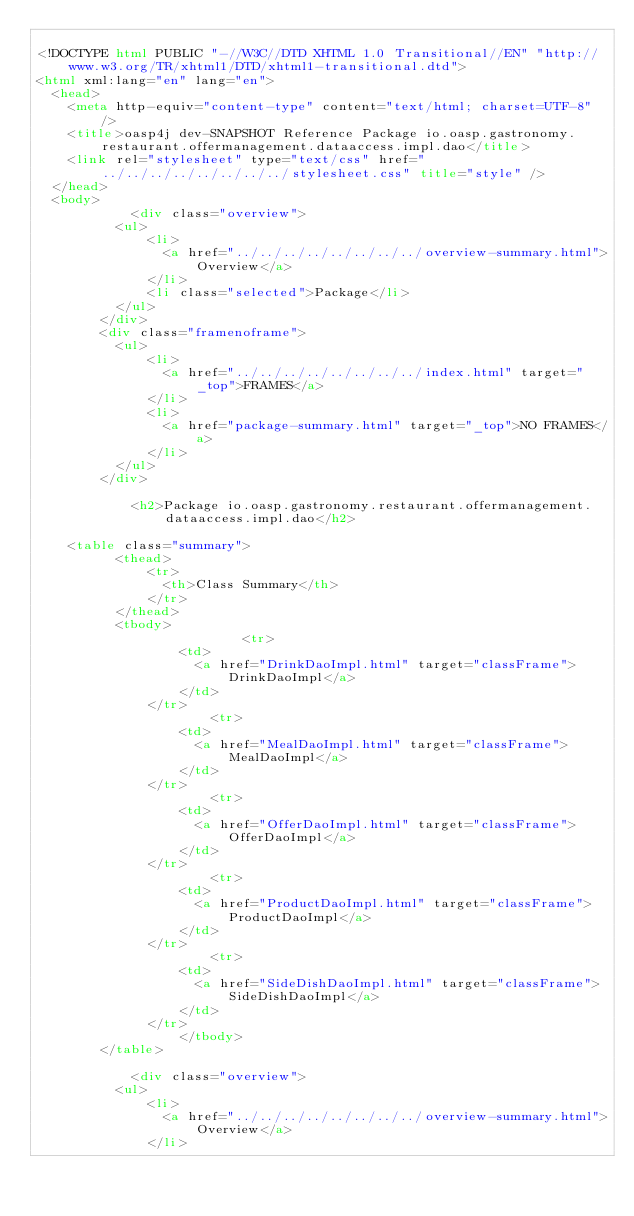Convert code to text. <code><loc_0><loc_0><loc_500><loc_500><_HTML_>
<!DOCTYPE html PUBLIC "-//W3C//DTD XHTML 1.0 Transitional//EN" "http://www.w3.org/TR/xhtml1/DTD/xhtml1-transitional.dtd">
<html xml:lang="en" lang="en">
	<head>
		<meta http-equiv="content-type" content="text/html; charset=UTF-8" />
		<title>oasp4j dev-SNAPSHOT Reference Package io.oasp.gastronomy.restaurant.offermanagement.dataaccess.impl.dao</title>
		<link rel="stylesheet" type="text/css" href="../../../../../../../../stylesheet.css" title="style" />
	</head>
	<body>
		      	<div class="overview">
        	<ul>
          		<li>
            		<a href="../../../../../../../../overview-summary.html">Overview</a>
          		</li>
          		<li class="selected">Package</li>
        	</ul>
      	</div>
      	<div class="framenoframe">
        	<ul>
          		<li>
            		<a href="../../../../../../../../index.html" target="_top">FRAMES</a>
          		</li>
          		<li>
            		<a href="package-summary.html" target="_top">NO FRAMES</a>
          		</li>
        	</ul>
      	</div>
		
		      	<h2>Package io.oasp.gastronomy.restaurant.offermanagement.dataaccess.impl.dao</h2>

		<table class="summary">
        	<thead>
          		<tr>
            		<th>Class Summary</th>
          		</tr>
        	</thead>
        	<tbody>
        		            	<tr>
              		<td>
                		<a href="DrinkDaoImpl.html" target="classFrame">DrinkDaoImpl</a>
              		</td>
            	</tr>
				            	<tr>
              		<td>
                		<a href="MealDaoImpl.html" target="classFrame">MealDaoImpl</a>
              		</td>
            	</tr>
				            	<tr>
              		<td>
                		<a href="OfferDaoImpl.html" target="classFrame">OfferDaoImpl</a>
              		</td>
            	</tr>
				            	<tr>
              		<td>
                		<a href="ProductDaoImpl.html" target="classFrame">ProductDaoImpl</a>
              		</td>
            	</tr>
				            	<tr>
              		<td>
                		<a href="SideDishDaoImpl.html" target="classFrame">SideDishDaoImpl</a>
              		</td>
            	</tr>
				        	</tbody>
      	</table>
		
		      	<div class="overview">
        	<ul>
          		<li>
            		<a href="../../../../../../../../overview-summary.html">Overview</a>
          		</li></code> 